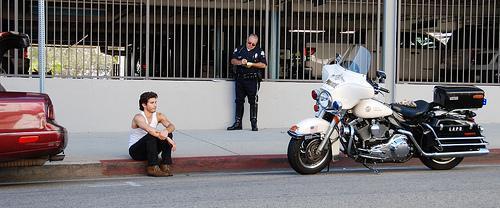How many people are there?
Give a very brief answer. 2. 